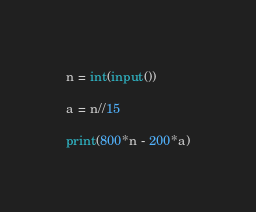Convert code to text. <code><loc_0><loc_0><loc_500><loc_500><_Python_>n = int(input())

a = n//15

print(800*n - 200*a)</code> 